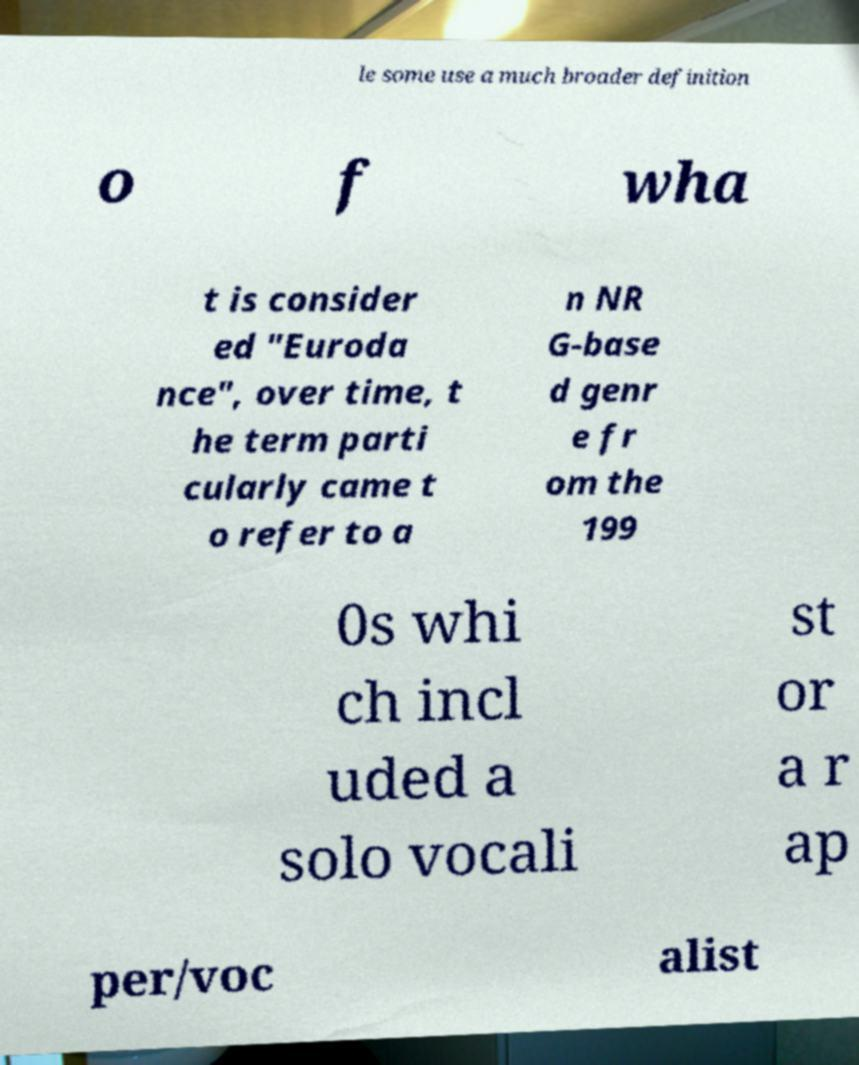Please read and relay the text visible in this image. What does it say? le some use a much broader definition o f wha t is consider ed "Euroda nce", over time, t he term parti cularly came t o refer to a n NR G-base d genr e fr om the 199 0s whi ch incl uded a solo vocali st or a r ap per/voc alist 